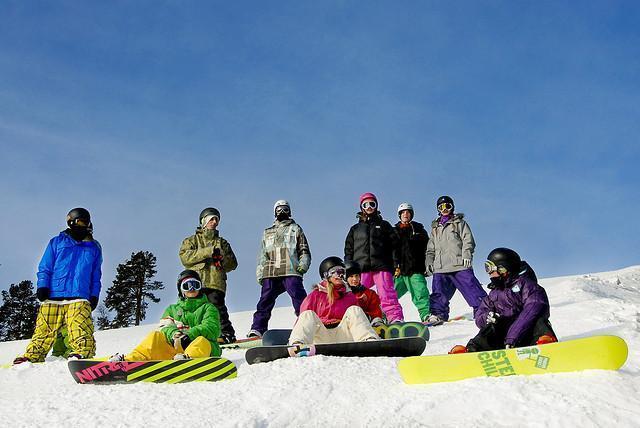How many snowboards are in the picture?
Give a very brief answer. 3. How many people are there?
Give a very brief answer. 9. 